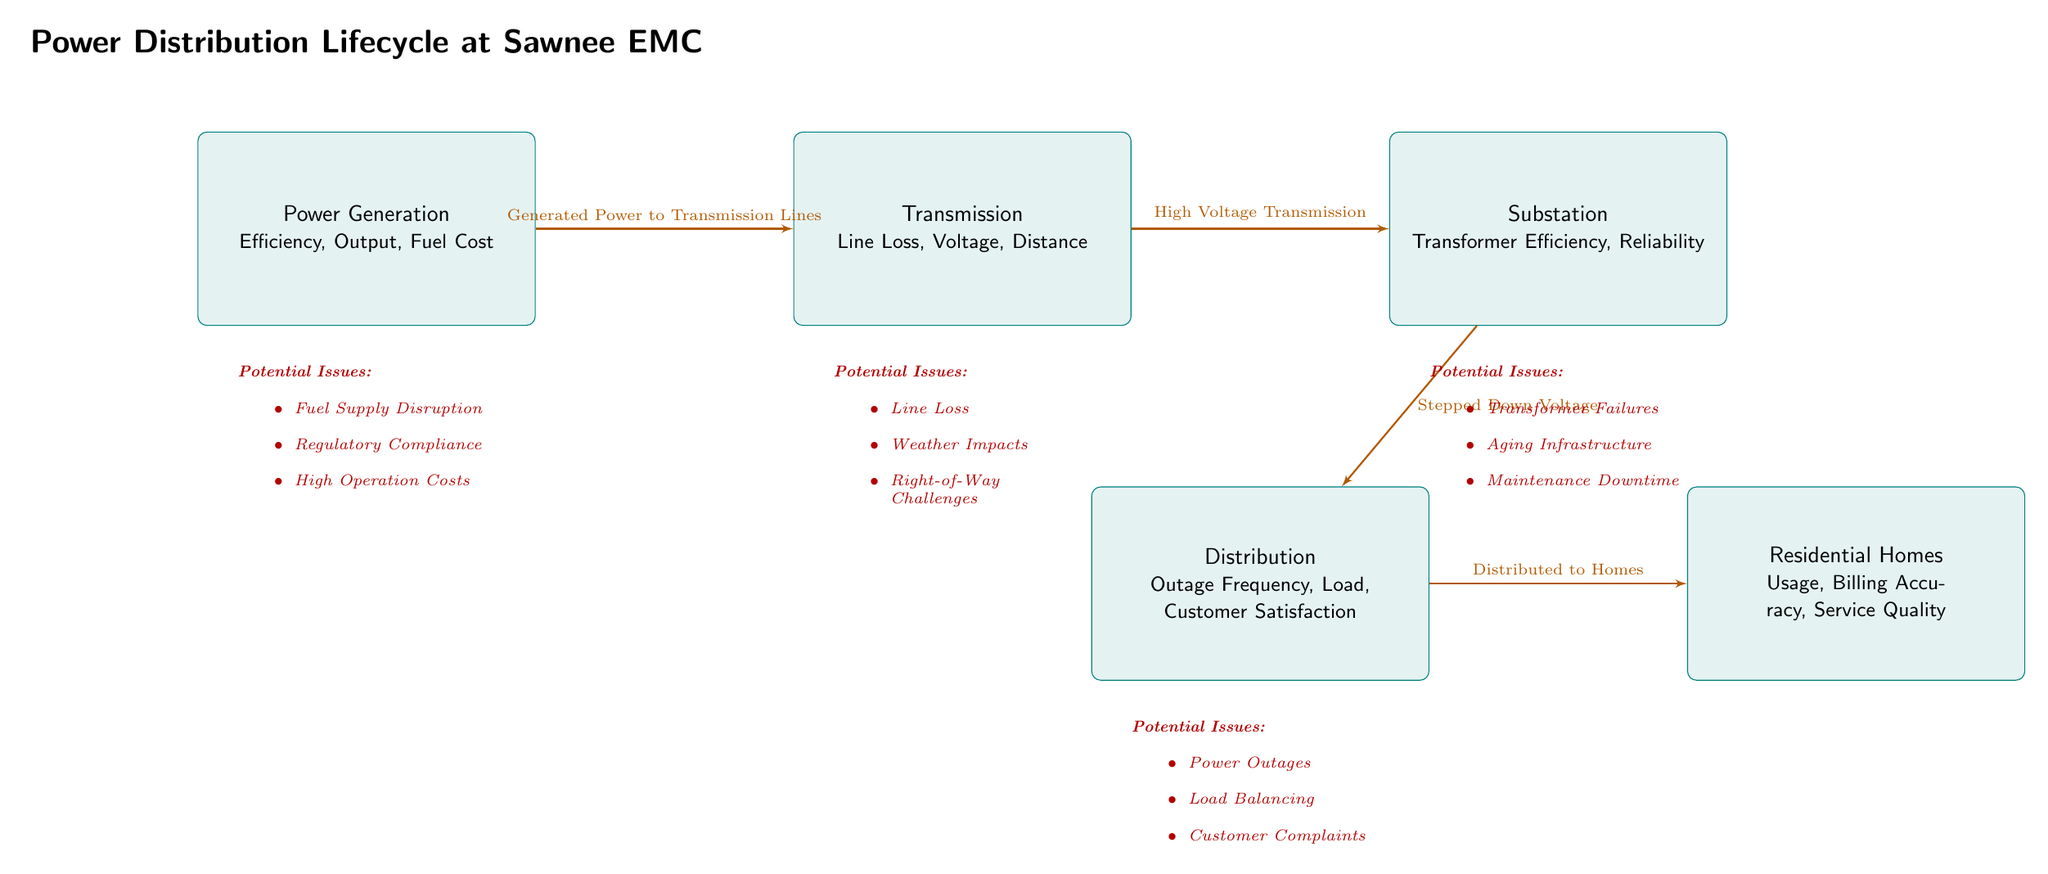What is the first stage in the power distribution lifecycle? The first stage is "Power Generation," which is represented as the leftmost box in the diagram. This box outlines the initial phase where electricity is produced before being transmitted.
Answer: Power Generation What is the last stage before electricity reaches residential homes? The last stage before reaching residential homes is "Distribution." This is represented as the box directly preceding the "Residential Homes" box, indicating that electricity is distributed to homes from this stage.
Answer: Distribution How many potential issues are listed under the "Substation" stage? There are three potential issues listed under the "Substation" stage: Transformer Failures, Aging Infrastructure, and Maintenance Downtime. These issues are addressed within the specified "issue" box under the "Substation" section.
Answer: 3 What type of transmission occurs between "Transmission" and "Substation"? The type of transmission that occurs is "High Voltage Transmission," as indicated by the label on the arrow connecting these two boxes. This highlights how electricity is sent at high voltage levels to minimize losses over long distances.
Answer: High Voltage Transmission Which stage is primarily concerned with customer satisfaction? The stage primarily concerned with customer satisfaction is "Distribution," as noted in its metrics section where it explicitly mentions "Customer Satisfaction" among other factors. This suggests that customer experiences are a key focus at this stage.
Answer: Distribution What are two potential issues related to the "Transmission" stage? Two potential issues related to the "Transmission" stage that can be found in the corresponding "issue" box are "Line Loss" and "Weather Impacts." These issues illustrate concerns that can affect the efficiency and reliability of electricity transmission.
Answer: Line Loss, Weather Impacts How does electricity flow from "Substation" to "Residential Homes"? Electricity flows from "Substation" to "Residential Homes" as indicated in the diagram label "Distributed to Homes," which signifies the transition of electricity from the substation level to individual residences.
Answer: Distributed to Homes What metric is associated with the "Generation" stage that reflects operation costs? The metric associated with the "Generation" stage reflecting operation costs is "Fuel Cost," as listed in the metrics section of the "Power Generation" box. This metric directly ties operational expenditure to fuel resources used in the generation of power.
Answer: Fuel Cost What challenges might be encountered regarding "Distribution"? Potential challenges regarding "Distribution" include "Power Outages," "Load Balancing," and "Customer Complaints," all of which are detailed under the potential issues listed for this stage. These challenges reflect the complexities involved in effectively managing electricity distribution.
Answer: Power Outages, Load Balancing, Customer Complaints 